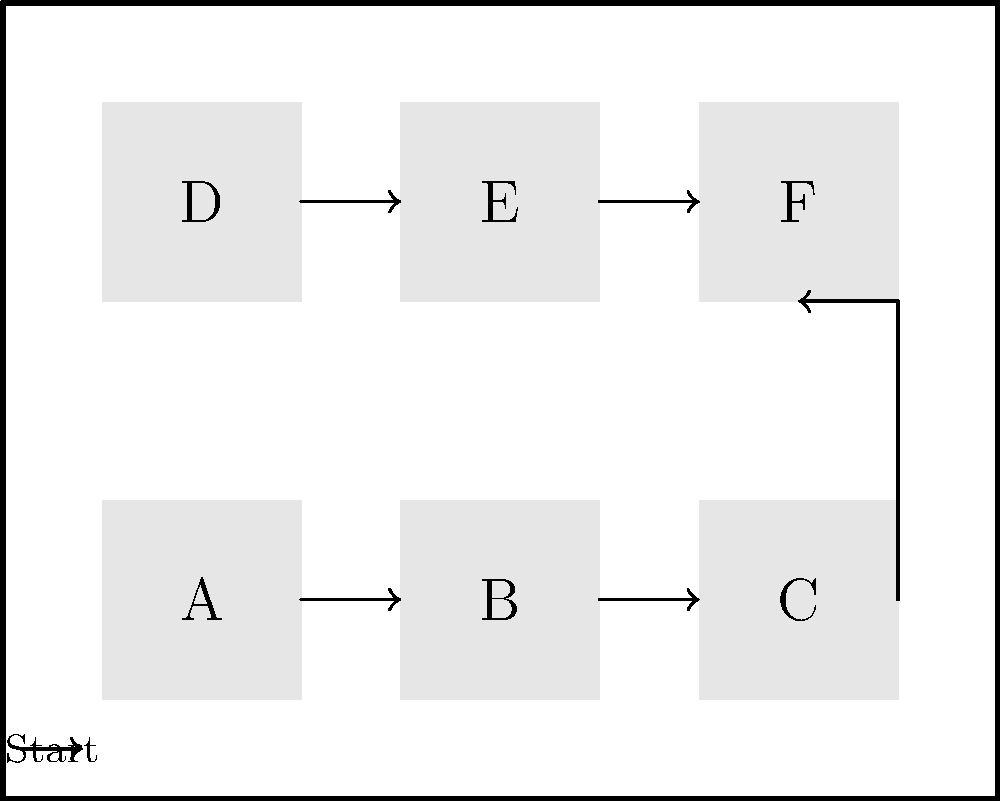A factory floor layout is shown above with six workstations labeled A through F. Workers move between stations following the arrows. To optimize workflow and reduce fatigue, you need to reorganize the layout. What is the minimum number of station relocations needed to ensure that workers always move in a single direction (left to right or top to bottom) without backtracking? To solve this problem, we need to analyze the current layout and identify the movements that cause backtracking:

1. The current flow is: A → B → C → F → E → D

2. Backtracking occurs when moving from C to F (right to left) and from E to D (right to left).

3. To eliminate backtracking, we need to ensure a left-to-right or top-to-bottom flow.

4. The optimal arrangement would be: A → B → C → D → E → F

5. To achieve this arrangement:
   - Stations A, B, and C can remain in their current positions.
   - Station D needs to move to the position currently occupied by F.
   - Station E can remain in its current position.
   - Station F needs to move to the position currently occupied by D.

6. In total, we need to swap the positions of stations D and F.

Therefore, the minimum number of station relocations needed is 2 (moving D and F).
Answer: 2 relocations 